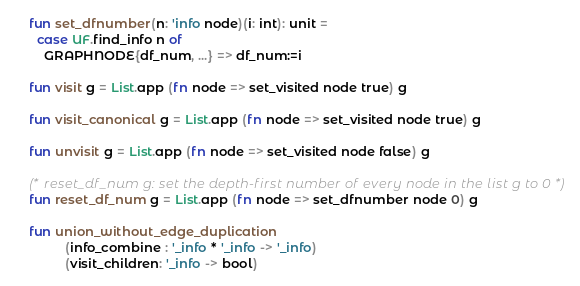Convert code to text. <code><loc_0><loc_0><loc_500><loc_500><_SML_>    fun set_dfnumber(n: 'info node)(i: int): unit =
      case UF.find_info n of
        GRAPHNODE{df_num, ...} => df_num:=i

    fun visit g = List.app (fn node => set_visited node true) g

    fun visit_canonical g = List.app (fn node => set_visited node true) g
   
    fun unvisit g = List.app (fn node => set_visited node false) g
   
    (* reset_df_num g: set the depth-first number of every node in the list g to 0 *)
    fun reset_df_num g = List.app (fn node => set_dfnumber node 0) g

    fun union_without_edge_duplication 
              (info_combine : '_info * '_info -> '_info) 
              (visit_children: '_info -> bool)</code> 